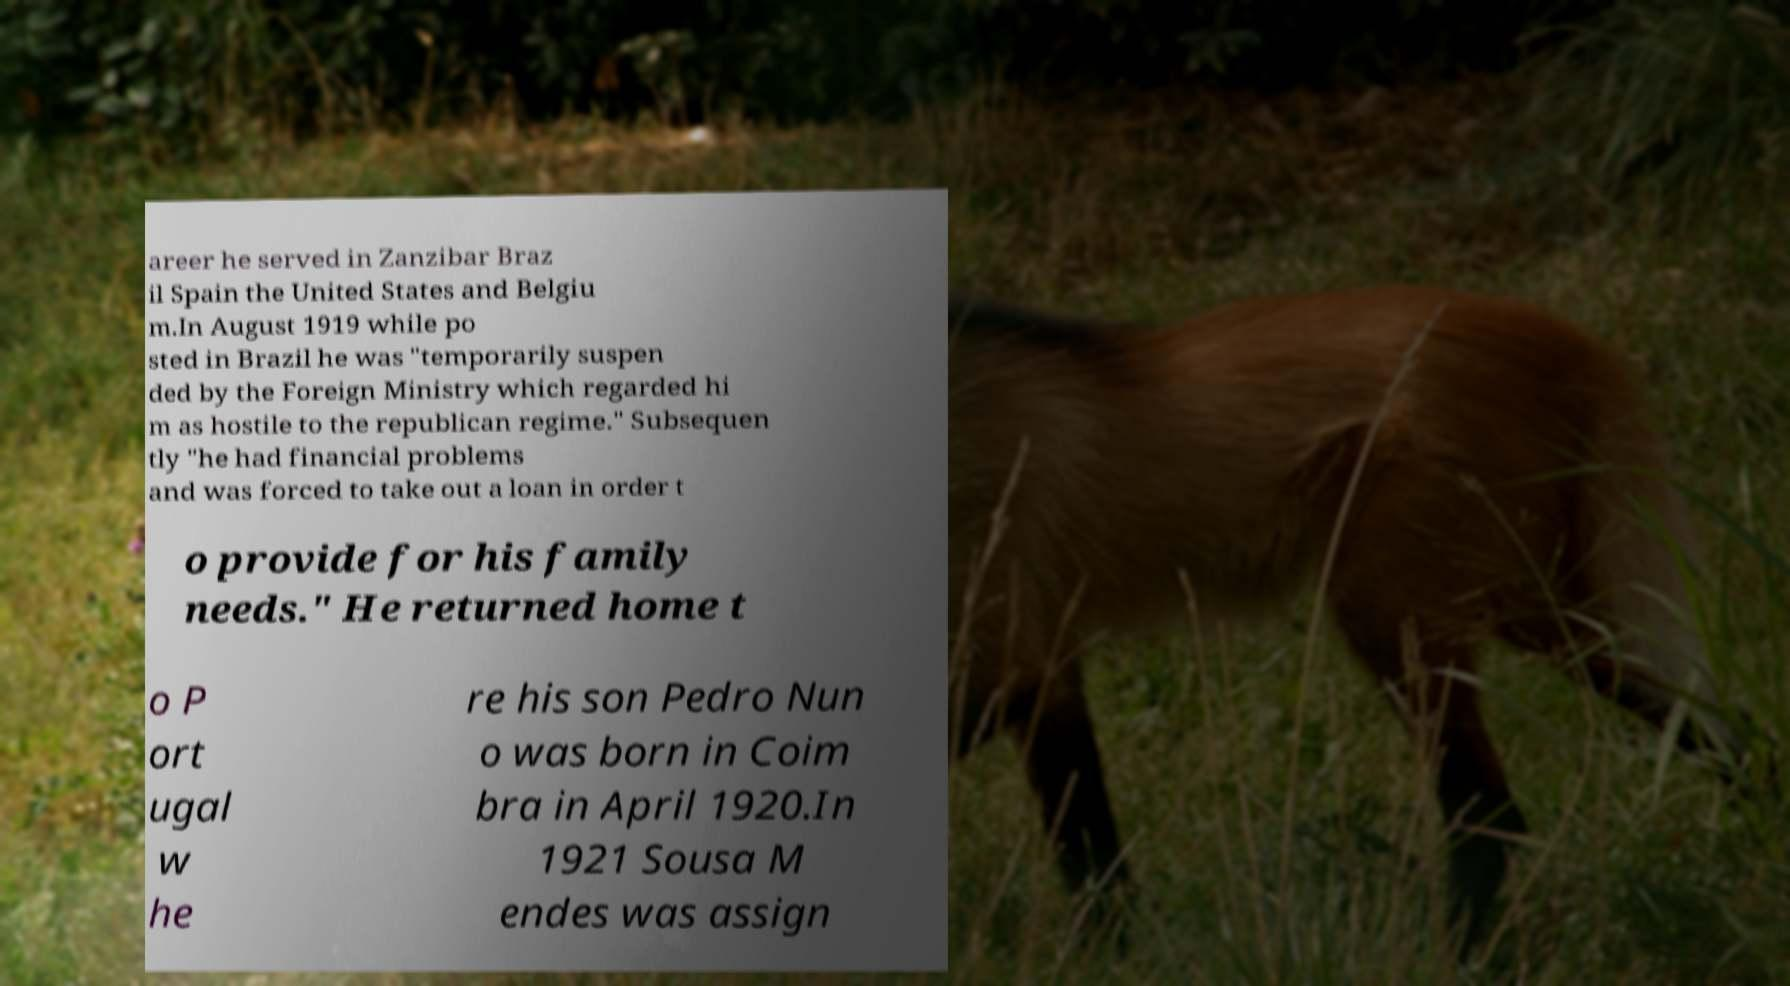I need the written content from this picture converted into text. Can you do that? areer he served in Zanzibar Braz il Spain the United States and Belgiu m.In August 1919 while po sted in Brazil he was "temporarily suspen ded by the Foreign Ministry which regarded hi m as hostile to the republican regime." Subsequen tly "he had financial problems and was forced to take out a loan in order t o provide for his family needs." He returned home t o P ort ugal w he re his son Pedro Nun o was born in Coim bra in April 1920.In 1921 Sousa M endes was assign 